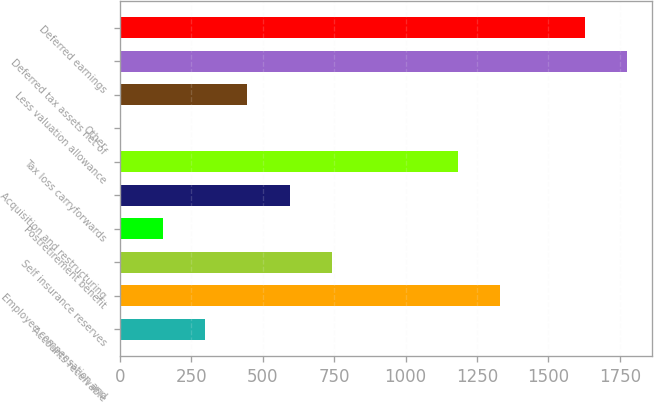Convert chart. <chart><loc_0><loc_0><loc_500><loc_500><bar_chart><fcel>Accounts receivable<fcel>Employee compensation and<fcel>Self insurance reserves<fcel>Postretirement benefit<fcel>Acquisition and restructuring<fcel>Tax loss carryforwards<fcel>Other<fcel>Less valuation allowance<fcel>Deferred tax assets net of<fcel>Deferred earnings<nl><fcel>299.3<fcel>1331.8<fcel>741.8<fcel>151.8<fcel>594.3<fcel>1184.3<fcel>4.3<fcel>446.8<fcel>1774.3<fcel>1626.8<nl></chart> 